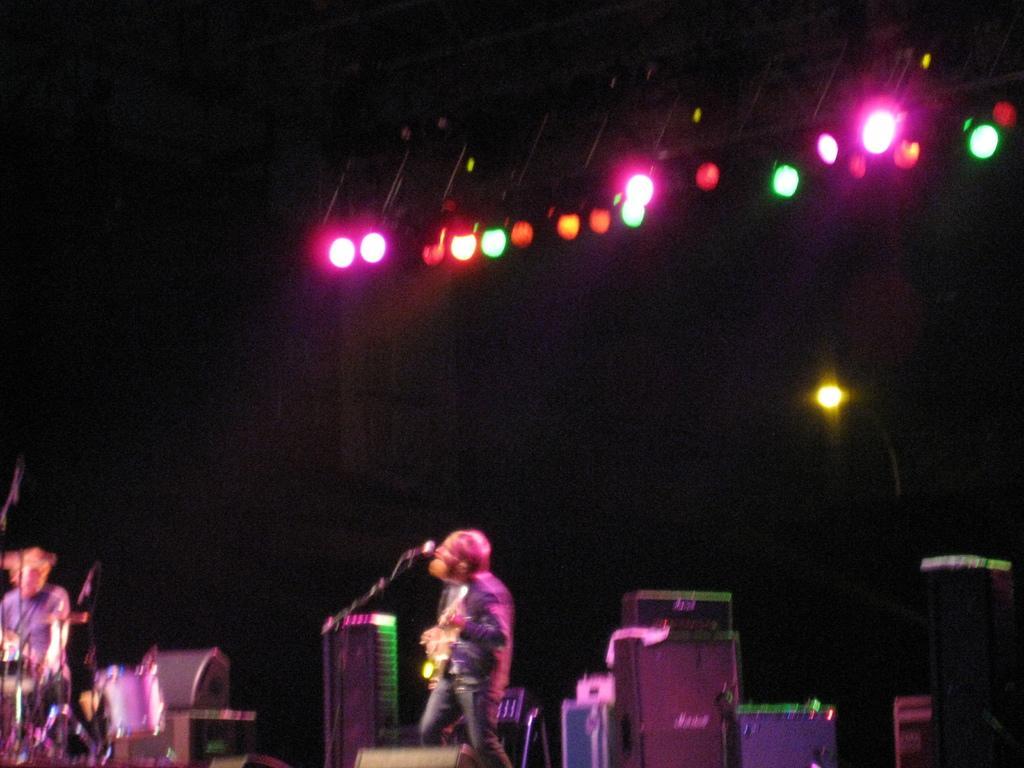Describe this image in one or two sentences. In this image I can see few people where one is standing and another one is sitting next to a drum set. I can also see a mic and few lights. 